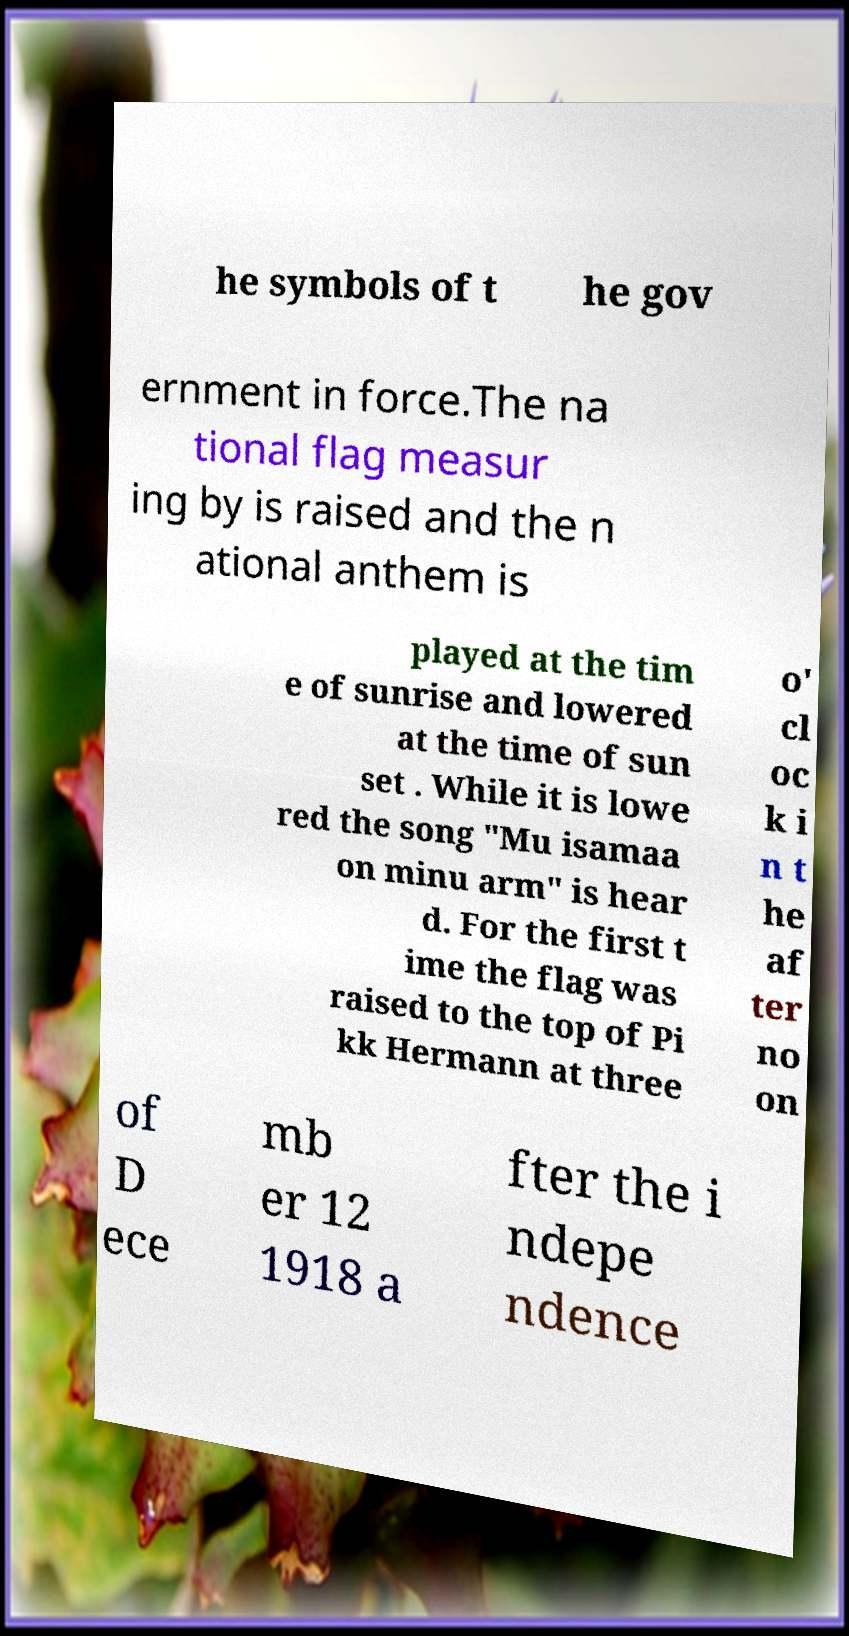Could you assist in decoding the text presented in this image and type it out clearly? he symbols of t he gov ernment in force.The na tional flag measur ing by is raised and the n ational anthem is played at the tim e of sunrise and lowered at the time of sun set . While it is lowe red the song "Mu isamaa on minu arm" is hear d. For the first t ime the flag was raised to the top of Pi kk Hermann at three o' cl oc k i n t he af ter no on of D ece mb er 12 1918 a fter the i ndepe ndence 